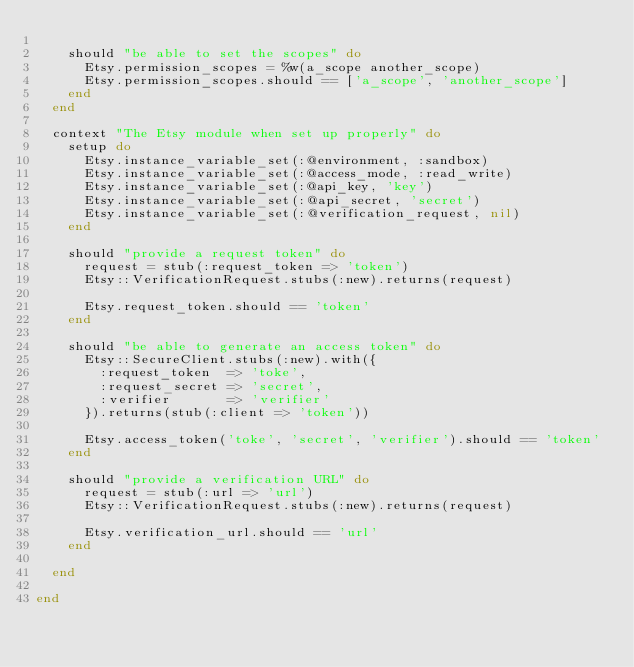Convert code to text. <code><loc_0><loc_0><loc_500><loc_500><_Ruby_>
    should "be able to set the scopes" do
      Etsy.permission_scopes = %w(a_scope another_scope)
      Etsy.permission_scopes.should == ['a_scope', 'another_scope']
    end
  end

  context "The Etsy module when set up properly" do
    setup do
      Etsy.instance_variable_set(:@environment, :sandbox)
      Etsy.instance_variable_set(:@access_mode, :read_write)
      Etsy.instance_variable_set(:@api_key, 'key')
      Etsy.instance_variable_set(:@api_secret, 'secret')
      Etsy.instance_variable_set(:@verification_request, nil)
    end

    should "provide a request token" do
      request = stub(:request_token => 'token')
      Etsy::VerificationRequest.stubs(:new).returns(request)

      Etsy.request_token.should == 'token'
    end

    should "be able to generate an access token" do
      Etsy::SecureClient.stubs(:new).with({
        :request_token  => 'toke',
        :request_secret => 'secret',
        :verifier       => 'verifier'
      }).returns(stub(:client => 'token'))

      Etsy.access_token('toke', 'secret', 'verifier').should == 'token'
    end

    should "provide a verification URL" do
      request = stub(:url => 'url')
      Etsy::VerificationRequest.stubs(:new).returns(request)

      Etsy.verification_url.should == 'url'
    end

  end

end
</code> 